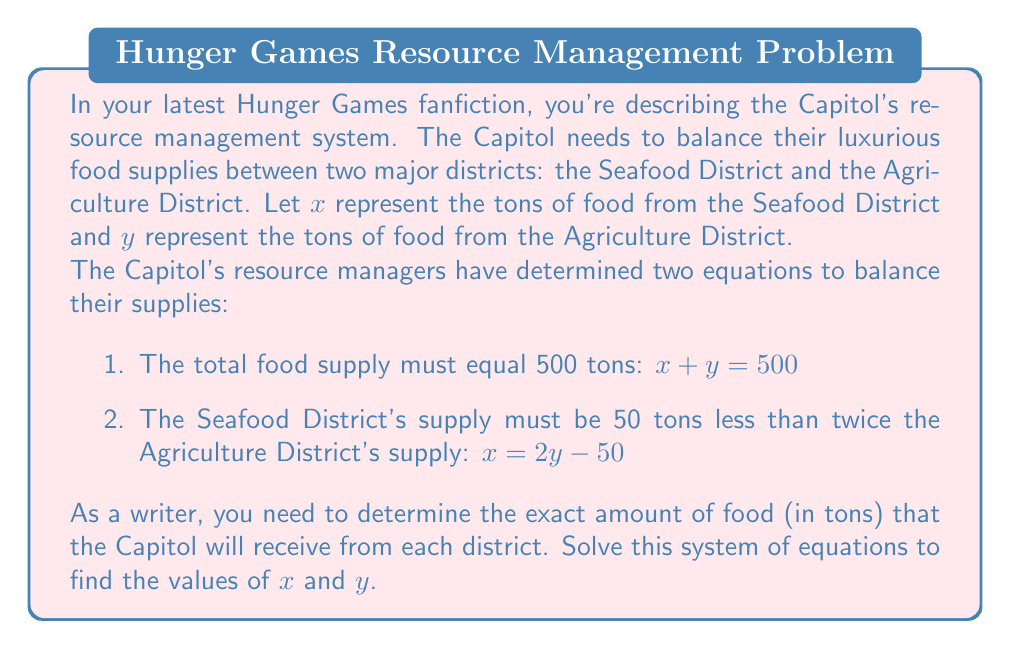What is the answer to this math problem? Let's solve this system of equations step by step:

1) We have two equations:
   $$x + y = 500$$ (Equation 1)
   $$x = 2y - 50$$ (Equation 2)

2) We can solve this by substitution. Let's substitute Equation 2 into Equation 1:
   $$(2y - 50) + y = 500$$

3) Simplify:
   $$2y - 50 + y = 500$$
   $$3y - 50 = 500$$

4) Add 50 to both sides:
   $$3y = 550$$

5) Divide both sides by 3:
   $$y = \frac{550}{3} \approx 183.33$$

6) Since we're dealing with tons of food, we'll round to the nearest whole number:
   $$y = 183$$ tons

7) Now that we know $y$, we can substitute this value back into Equation 2 to find $x$:
   $$x = 2y - 50$$
   $$x = 2(183) - 50$$
   $$x = 366 - 50 = 316$$ tons

8) We can verify our solution by checking if it satisfies Equation 1:
   $$316 + 183 = 499$$

   This is off by 1 due to rounding, which is acceptable for this context.
Answer: The Capitol will receive approximately 316 tons of food from the Seafood District ($x$) and 183 tons of food from the Agriculture District ($y$). 